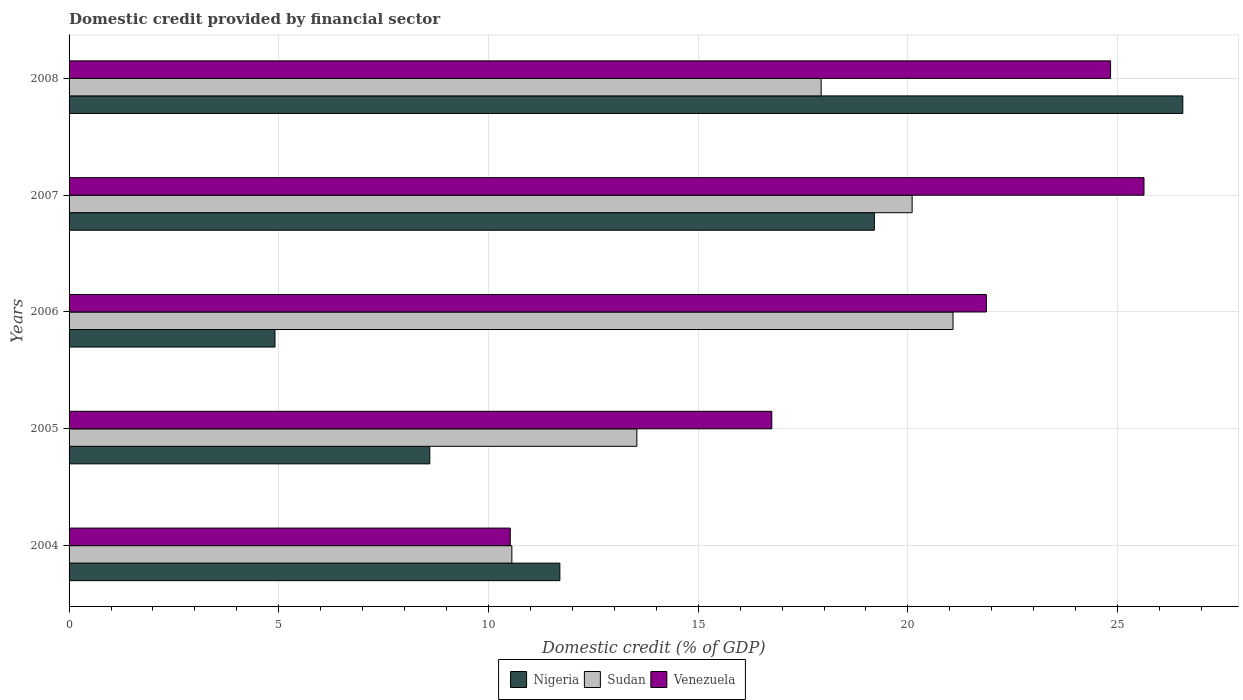How many groups of bars are there?
Make the answer very short. 5. Are the number of bars per tick equal to the number of legend labels?
Your response must be concise. Yes. Are the number of bars on each tick of the Y-axis equal?
Ensure brevity in your answer.  Yes. How many bars are there on the 2nd tick from the top?
Your response must be concise. 3. How many bars are there on the 1st tick from the bottom?
Offer a very short reply. 3. What is the label of the 1st group of bars from the top?
Make the answer very short. 2008. What is the domestic credit in Sudan in 2007?
Your response must be concise. 20.1. Across all years, what is the maximum domestic credit in Venezuela?
Offer a very short reply. 25.63. Across all years, what is the minimum domestic credit in Nigeria?
Offer a very short reply. 4.91. In which year was the domestic credit in Nigeria maximum?
Offer a very short reply. 2008. In which year was the domestic credit in Venezuela minimum?
Offer a terse response. 2004. What is the total domestic credit in Sudan in the graph?
Your response must be concise. 83.2. What is the difference between the domestic credit in Venezuela in 2004 and that in 2006?
Make the answer very short. -11.35. What is the difference between the domestic credit in Nigeria in 2004 and the domestic credit in Sudan in 2008?
Your answer should be compact. -6.23. What is the average domestic credit in Nigeria per year?
Your response must be concise. 14.19. In the year 2004, what is the difference between the domestic credit in Venezuela and domestic credit in Nigeria?
Provide a succinct answer. -1.18. In how many years, is the domestic credit in Sudan greater than 20 %?
Keep it short and to the point. 2. What is the ratio of the domestic credit in Sudan in 2006 to that in 2007?
Keep it short and to the point. 1.05. What is the difference between the highest and the second highest domestic credit in Sudan?
Keep it short and to the point. 0.97. What is the difference between the highest and the lowest domestic credit in Sudan?
Give a very brief answer. 10.52. Is the sum of the domestic credit in Nigeria in 2004 and 2008 greater than the maximum domestic credit in Sudan across all years?
Make the answer very short. Yes. What does the 1st bar from the top in 2008 represents?
Make the answer very short. Venezuela. What does the 3rd bar from the bottom in 2006 represents?
Make the answer very short. Venezuela. Is it the case that in every year, the sum of the domestic credit in Sudan and domestic credit in Venezuela is greater than the domestic credit in Nigeria?
Keep it short and to the point. Yes. What is the difference between two consecutive major ticks on the X-axis?
Provide a succinct answer. 5. Does the graph contain any zero values?
Offer a terse response. No. Does the graph contain grids?
Offer a very short reply. Yes. Where does the legend appear in the graph?
Your answer should be compact. Bottom center. How many legend labels are there?
Give a very brief answer. 3. How are the legend labels stacked?
Your response must be concise. Horizontal. What is the title of the graph?
Offer a very short reply. Domestic credit provided by financial sector. Does "Qatar" appear as one of the legend labels in the graph?
Your answer should be very brief. No. What is the label or title of the X-axis?
Give a very brief answer. Domestic credit (% of GDP). What is the Domestic credit (% of GDP) of Nigeria in 2004?
Make the answer very short. 11.7. What is the Domestic credit (% of GDP) in Sudan in 2004?
Provide a short and direct response. 10.56. What is the Domestic credit (% of GDP) of Venezuela in 2004?
Give a very brief answer. 10.52. What is the Domestic credit (% of GDP) in Nigeria in 2005?
Your answer should be compact. 8.6. What is the Domestic credit (% of GDP) of Sudan in 2005?
Make the answer very short. 13.54. What is the Domestic credit (% of GDP) in Venezuela in 2005?
Make the answer very short. 16.75. What is the Domestic credit (% of GDP) in Nigeria in 2006?
Keep it short and to the point. 4.91. What is the Domestic credit (% of GDP) in Sudan in 2006?
Keep it short and to the point. 21.08. What is the Domestic credit (% of GDP) of Venezuela in 2006?
Your response must be concise. 21.87. What is the Domestic credit (% of GDP) of Nigeria in 2007?
Provide a short and direct response. 19.2. What is the Domestic credit (% of GDP) of Sudan in 2007?
Your response must be concise. 20.1. What is the Domestic credit (% of GDP) in Venezuela in 2007?
Provide a succinct answer. 25.63. What is the Domestic credit (% of GDP) of Nigeria in 2008?
Your answer should be very brief. 26.55. What is the Domestic credit (% of GDP) in Sudan in 2008?
Your response must be concise. 17.93. What is the Domestic credit (% of GDP) in Venezuela in 2008?
Your answer should be very brief. 24.83. Across all years, what is the maximum Domestic credit (% of GDP) of Nigeria?
Make the answer very short. 26.55. Across all years, what is the maximum Domestic credit (% of GDP) in Sudan?
Ensure brevity in your answer.  21.08. Across all years, what is the maximum Domestic credit (% of GDP) in Venezuela?
Give a very brief answer. 25.63. Across all years, what is the minimum Domestic credit (% of GDP) in Nigeria?
Make the answer very short. 4.91. Across all years, what is the minimum Domestic credit (% of GDP) of Sudan?
Offer a terse response. 10.56. Across all years, what is the minimum Domestic credit (% of GDP) in Venezuela?
Offer a terse response. 10.52. What is the total Domestic credit (% of GDP) of Nigeria in the graph?
Provide a short and direct response. 70.96. What is the total Domestic credit (% of GDP) of Sudan in the graph?
Offer a terse response. 83.2. What is the total Domestic credit (% of GDP) of Venezuela in the graph?
Give a very brief answer. 99.6. What is the difference between the Domestic credit (% of GDP) of Nigeria in 2004 and that in 2005?
Your response must be concise. 3.1. What is the difference between the Domestic credit (% of GDP) in Sudan in 2004 and that in 2005?
Give a very brief answer. -2.98. What is the difference between the Domestic credit (% of GDP) of Venezuela in 2004 and that in 2005?
Make the answer very short. -6.24. What is the difference between the Domestic credit (% of GDP) of Nigeria in 2004 and that in 2006?
Offer a very short reply. 6.79. What is the difference between the Domestic credit (% of GDP) in Sudan in 2004 and that in 2006?
Provide a short and direct response. -10.52. What is the difference between the Domestic credit (% of GDP) of Venezuela in 2004 and that in 2006?
Your response must be concise. -11.35. What is the difference between the Domestic credit (% of GDP) in Nigeria in 2004 and that in 2007?
Your answer should be compact. -7.5. What is the difference between the Domestic credit (% of GDP) of Sudan in 2004 and that in 2007?
Your response must be concise. -9.54. What is the difference between the Domestic credit (% of GDP) in Venezuela in 2004 and that in 2007?
Make the answer very short. -15.11. What is the difference between the Domestic credit (% of GDP) in Nigeria in 2004 and that in 2008?
Provide a succinct answer. -14.85. What is the difference between the Domestic credit (% of GDP) in Sudan in 2004 and that in 2008?
Keep it short and to the point. -7.37. What is the difference between the Domestic credit (% of GDP) in Venezuela in 2004 and that in 2008?
Offer a terse response. -14.31. What is the difference between the Domestic credit (% of GDP) in Nigeria in 2005 and that in 2006?
Your response must be concise. 3.69. What is the difference between the Domestic credit (% of GDP) of Sudan in 2005 and that in 2006?
Provide a short and direct response. -7.54. What is the difference between the Domestic credit (% of GDP) of Venezuela in 2005 and that in 2006?
Provide a succinct answer. -5.12. What is the difference between the Domestic credit (% of GDP) in Nigeria in 2005 and that in 2007?
Provide a succinct answer. -10.6. What is the difference between the Domestic credit (% of GDP) of Sudan in 2005 and that in 2007?
Provide a short and direct response. -6.56. What is the difference between the Domestic credit (% of GDP) of Venezuela in 2005 and that in 2007?
Make the answer very short. -8.87. What is the difference between the Domestic credit (% of GDP) in Nigeria in 2005 and that in 2008?
Your answer should be very brief. -17.95. What is the difference between the Domestic credit (% of GDP) in Sudan in 2005 and that in 2008?
Provide a short and direct response. -4.39. What is the difference between the Domestic credit (% of GDP) of Venezuela in 2005 and that in 2008?
Offer a terse response. -8.08. What is the difference between the Domestic credit (% of GDP) in Nigeria in 2006 and that in 2007?
Your answer should be very brief. -14.29. What is the difference between the Domestic credit (% of GDP) in Sudan in 2006 and that in 2007?
Give a very brief answer. 0.97. What is the difference between the Domestic credit (% of GDP) in Venezuela in 2006 and that in 2007?
Make the answer very short. -3.76. What is the difference between the Domestic credit (% of GDP) in Nigeria in 2006 and that in 2008?
Provide a short and direct response. -21.64. What is the difference between the Domestic credit (% of GDP) of Sudan in 2006 and that in 2008?
Offer a very short reply. 3.14. What is the difference between the Domestic credit (% of GDP) of Venezuela in 2006 and that in 2008?
Your answer should be very brief. -2.96. What is the difference between the Domestic credit (% of GDP) in Nigeria in 2007 and that in 2008?
Your answer should be compact. -7.35. What is the difference between the Domestic credit (% of GDP) of Sudan in 2007 and that in 2008?
Provide a short and direct response. 2.17. What is the difference between the Domestic credit (% of GDP) of Venezuela in 2007 and that in 2008?
Your response must be concise. 0.8. What is the difference between the Domestic credit (% of GDP) in Nigeria in 2004 and the Domestic credit (% of GDP) in Sudan in 2005?
Offer a terse response. -1.84. What is the difference between the Domestic credit (% of GDP) of Nigeria in 2004 and the Domestic credit (% of GDP) of Venezuela in 2005?
Offer a very short reply. -5.05. What is the difference between the Domestic credit (% of GDP) in Sudan in 2004 and the Domestic credit (% of GDP) in Venezuela in 2005?
Give a very brief answer. -6.2. What is the difference between the Domestic credit (% of GDP) in Nigeria in 2004 and the Domestic credit (% of GDP) in Sudan in 2006?
Make the answer very short. -9.37. What is the difference between the Domestic credit (% of GDP) of Nigeria in 2004 and the Domestic credit (% of GDP) of Venezuela in 2006?
Offer a very short reply. -10.17. What is the difference between the Domestic credit (% of GDP) in Sudan in 2004 and the Domestic credit (% of GDP) in Venezuela in 2006?
Make the answer very short. -11.31. What is the difference between the Domestic credit (% of GDP) in Nigeria in 2004 and the Domestic credit (% of GDP) in Sudan in 2007?
Keep it short and to the point. -8.4. What is the difference between the Domestic credit (% of GDP) of Nigeria in 2004 and the Domestic credit (% of GDP) of Venezuela in 2007?
Keep it short and to the point. -13.93. What is the difference between the Domestic credit (% of GDP) in Sudan in 2004 and the Domestic credit (% of GDP) in Venezuela in 2007?
Make the answer very short. -15.07. What is the difference between the Domestic credit (% of GDP) of Nigeria in 2004 and the Domestic credit (% of GDP) of Sudan in 2008?
Your answer should be compact. -6.23. What is the difference between the Domestic credit (% of GDP) in Nigeria in 2004 and the Domestic credit (% of GDP) in Venezuela in 2008?
Your answer should be very brief. -13.13. What is the difference between the Domestic credit (% of GDP) in Sudan in 2004 and the Domestic credit (% of GDP) in Venezuela in 2008?
Ensure brevity in your answer.  -14.27. What is the difference between the Domestic credit (% of GDP) of Nigeria in 2005 and the Domestic credit (% of GDP) of Sudan in 2006?
Provide a succinct answer. -12.47. What is the difference between the Domestic credit (% of GDP) of Nigeria in 2005 and the Domestic credit (% of GDP) of Venezuela in 2006?
Your answer should be compact. -13.27. What is the difference between the Domestic credit (% of GDP) in Sudan in 2005 and the Domestic credit (% of GDP) in Venezuela in 2006?
Your answer should be compact. -8.33. What is the difference between the Domestic credit (% of GDP) of Nigeria in 2005 and the Domestic credit (% of GDP) of Sudan in 2007?
Ensure brevity in your answer.  -11.5. What is the difference between the Domestic credit (% of GDP) in Nigeria in 2005 and the Domestic credit (% of GDP) in Venezuela in 2007?
Offer a terse response. -17.03. What is the difference between the Domestic credit (% of GDP) in Sudan in 2005 and the Domestic credit (% of GDP) in Venezuela in 2007?
Provide a succinct answer. -12.09. What is the difference between the Domestic credit (% of GDP) of Nigeria in 2005 and the Domestic credit (% of GDP) of Sudan in 2008?
Your answer should be very brief. -9.33. What is the difference between the Domestic credit (% of GDP) of Nigeria in 2005 and the Domestic credit (% of GDP) of Venezuela in 2008?
Ensure brevity in your answer.  -16.23. What is the difference between the Domestic credit (% of GDP) in Sudan in 2005 and the Domestic credit (% of GDP) in Venezuela in 2008?
Ensure brevity in your answer.  -11.29. What is the difference between the Domestic credit (% of GDP) of Nigeria in 2006 and the Domestic credit (% of GDP) of Sudan in 2007?
Give a very brief answer. -15.19. What is the difference between the Domestic credit (% of GDP) in Nigeria in 2006 and the Domestic credit (% of GDP) in Venezuela in 2007?
Keep it short and to the point. -20.72. What is the difference between the Domestic credit (% of GDP) of Sudan in 2006 and the Domestic credit (% of GDP) of Venezuela in 2007?
Offer a very short reply. -4.55. What is the difference between the Domestic credit (% of GDP) in Nigeria in 2006 and the Domestic credit (% of GDP) in Sudan in 2008?
Ensure brevity in your answer.  -13.02. What is the difference between the Domestic credit (% of GDP) of Nigeria in 2006 and the Domestic credit (% of GDP) of Venezuela in 2008?
Keep it short and to the point. -19.92. What is the difference between the Domestic credit (% of GDP) of Sudan in 2006 and the Domestic credit (% of GDP) of Venezuela in 2008?
Ensure brevity in your answer.  -3.76. What is the difference between the Domestic credit (% of GDP) in Nigeria in 2007 and the Domestic credit (% of GDP) in Sudan in 2008?
Give a very brief answer. 1.27. What is the difference between the Domestic credit (% of GDP) in Nigeria in 2007 and the Domestic credit (% of GDP) in Venezuela in 2008?
Provide a short and direct response. -5.63. What is the difference between the Domestic credit (% of GDP) in Sudan in 2007 and the Domestic credit (% of GDP) in Venezuela in 2008?
Your response must be concise. -4.73. What is the average Domestic credit (% of GDP) of Nigeria per year?
Offer a terse response. 14.19. What is the average Domestic credit (% of GDP) of Sudan per year?
Your response must be concise. 16.64. What is the average Domestic credit (% of GDP) of Venezuela per year?
Your answer should be compact. 19.92. In the year 2004, what is the difference between the Domestic credit (% of GDP) of Nigeria and Domestic credit (% of GDP) of Sudan?
Offer a terse response. 1.14. In the year 2004, what is the difference between the Domestic credit (% of GDP) in Nigeria and Domestic credit (% of GDP) in Venezuela?
Provide a short and direct response. 1.18. In the year 2004, what is the difference between the Domestic credit (% of GDP) of Sudan and Domestic credit (% of GDP) of Venezuela?
Keep it short and to the point. 0.04. In the year 2005, what is the difference between the Domestic credit (% of GDP) in Nigeria and Domestic credit (% of GDP) in Sudan?
Your answer should be compact. -4.94. In the year 2005, what is the difference between the Domestic credit (% of GDP) of Nigeria and Domestic credit (% of GDP) of Venezuela?
Provide a succinct answer. -8.15. In the year 2005, what is the difference between the Domestic credit (% of GDP) of Sudan and Domestic credit (% of GDP) of Venezuela?
Provide a succinct answer. -3.22. In the year 2006, what is the difference between the Domestic credit (% of GDP) of Nigeria and Domestic credit (% of GDP) of Sudan?
Offer a terse response. -16.17. In the year 2006, what is the difference between the Domestic credit (% of GDP) in Nigeria and Domestic credit (% of GDP) in Venezuela?
Keep it short and to the point. -16.96. In the year 2006, what is the difference between the Domestic credit (% of GDP) of Sudan and Domestic credit (% of GDP) of Venezuela?
Provide a succinct answer. -0.79. In the year 2007, what is the difference between the Domestic credit (% of GDP) of Nigeria and Domestic credit (% of GDP) of Sudan?
Provide a succinct answer. -0.9. In the year 2007, what is the difference between the Domestic credit (% of GDP) in Nigeria and Domestic credit (% of GDP) in Venezuela?
Your answer should be very brief. -6.43. In the year 2007, what is the difference between the Domestic credit (% of GDP) of Sudan and Domestic credit (% of GDP) of Venezuela?
Provide a short and direct response. -5.53. In the year 2008, what is the difference between the Domestic credit (% of GDP) in Nigeria and Domestic credit (% of GDP) in Sudan?
Offer a terse response. 8.62. In the year 2008, what is the difference between the Domestic credit (% of GDP) of Nigeria and Domestic credit (% of GDP) of Venezuela?
Make the answer very short. 1.72. In the year 2008, what is the difference between the Domestic credit (% of GDP) of Sudan and Domestic credit (% of GDP) of Venezuela?
Keep it short and to the point. -6.9. What is the ratio of the Domestic credit (% of GDP) of Nigeria in 2004 to that in 2005?
Your response must be concise. 1.36. What is the ratio of the Domestic credit (% of GDP) in Sudan in 2004 to that in 2005?
Provide a short and direct response. 0.78. What is the ratio of the Domestic credit (% of GDP) of Venezuela in 2004 to that in 2005?
Offer a very short reply. 0.63. What is the ratio of the Domestic credit (% of GDP) of Nigeria in 2004 to that in 2006?
Provide a succinct answer. 2.38. What is the ratio of the Domestic credit (% of GDP) of Sudan in 2004 to that in 2006?
Offer a very short reply. 0.5. What is the ratio of the Domestic credit (% of GDP) of Venezuela in 2004 to that in 2006?
Give a very brief answer. 0.48. What is the ratio of the Domestic credit (% of GDP) of Nigeria in 2004 to that in 2007?
Your answer should be compact. 0.61. What is the ratio of the Domestic credit (% of GDP) of Sudan in 2004 to that in 2007?
Your response must be concise. 0.53. What is the ratio of the Domestic credit (% of GDP) of Venezuela in 2004 to that in 2007?
Ensure brevity in your answer.  0.41. What is the ratio of the Domestic credit (% of GDP) in Nigeria in 2004 to that in 2008?
Offer a terse response. 0.44. What is the ratio of the Domestic credit (% of GDP) of Sudan in 2004 to that in 2008?
Ensure brevity in your answer.  0.59. What is the ratio of the Domestic credit (% of GDP) of Venezuela in 2004 to that in 2008?
Provide a short and direct response. 0.42. What is the ratio of the Domestic credit (% of GDP) of Nigeria in 2005 to that in 2006?
Give a very brief answer. 1.75. What is the ratio of the Domestic credit (% of GDP) in Sudan in 2005 to that in 2006?
Provide a succinct answer. 0.64. What is the ratio of the Domestic credit (% of GDP) in Venezuela in 2005 to that in 2006?
Give a very brief answer. 0.77. What is the ratio of the Domestic credit (% of GDP) of Nigeria in 2005 to that in 2007?
Provide a short and direct response. 0.45. What is the ratio of the Domestic credit (% of GDP) in Sudan in 2005 to that in 2007?
Make the answer very short. 0.67. What is the ratio of the Domestic credit (% of GDP) of Venezuela in 2005 to that in 2007?
Ensure brevity in your answer.  0.65. What is the ratio of the Domestic credit (% of GDP) of Nigeria in 2005 to that in 2008?
Give a very brief answer. 0.32. What is the ratio of the Domestic credit (% of GDP) in Sudan in 2005 to that in 2008?
Offer a terse response. 0.76. What is the ratio of the Domestic credit (% of GDP) of Venezuela in 2005 to that in 2008?
Provide a short and direct response. 0.67. What is the ratio of the Domestic credit (% of GDP) of Nigeria in 2006 to that in 2007?
Your response must be concise. 0.26. What is the ratio of the Domestic credit (% of GDP) of Sudan in 2006 to that in 2007?
Your answer should be compact. 1.05. What is the ratio of the Domestic credit (% of GDP) of Venezuela in 2006 to that in 2007?
Provide a short and direct response. 0.85. What is the ratio of the Domestic credit (% of GDP) of Nigeria in 2006 to that in 2008?
Provide a succinct answer. 0.18. What is the ratio of the Domestic credit (% of GDP) of Sudan in 2006 to that in 2008?
Ensure brevity in your answer.  1.18. What is the ratio of the Domestic credit (% of GDP) of Venezuela in 2006 to that in 2008?
Make the answer very short. 0.88. What is the ratio of the Domestic credit (% of GDP) in Nigeria in 2007 to that in 2008?
Your answer should be very brief. 0.72. What is the ratio of the Domestic credit (% of GDP) of Sudan in 2007 to that in 2008?
Provide a short and direct response. 1.12. What is the ratio of the Domestic credit (% of GDP) in Venezuela in 2007 to that in 2008?
Keep it short and to the point. 1.03. What is the difference between the highest and the second highest Domestic credit (% of GDP) of Nigeria?
Provide a short and direct response. 7.35. What is the difference between the highest and the second highest Domestic credit (% of GDP) of Sudan?
Provide a succinct answer. 0.97. What is the difference between the highest and the second highest Domestic credit (% of GDP) in Venezuela?
Give a very brief answer. 0.8. What is the difference between the highest and the lowest Domestic credit (% of GDP) in Nigeria?
Give a very brief answer. 21.64. What is the difference between the highest and the lowest Domestic credit (% of GDP) in Sudan?
Ensure brevity in your answer.  10.52. What is the difference between the highest and the lowest Domestic credit (% of GDP) of Venezuela?
Give a very brief answer. 15.11. 